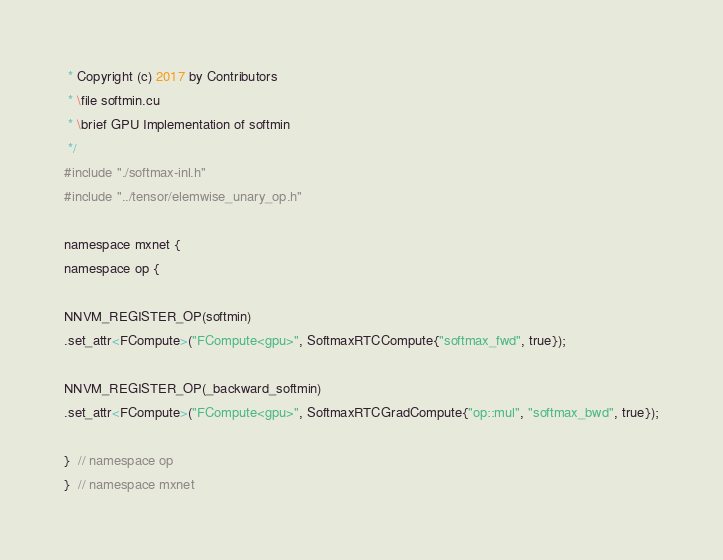Convert code to text. <code><loc_0><loc_0><loc_500><loc_500><_Cuda_> * Copyright (c) 2017 by Contributors
 * \file softmin.cu
 * \brief GPU Implementation of softmin
 */
#include "./softmax-inl.h"
#include "../tensor/elemwise_unary_op.h"

namespace mxnet {
namespace op {

NNVM_REGISTER_OP(softmin)
.set_attr<FCompute>("FCompute<gpu>", SoftmaxRTCCompute{"softmax_fwd", true});

NNVM_REGISTER_OP(_backward_softmin)
.set_attr<FCompute>("FCompute<gpu>", SoftmaxRTCGradCompute{"op::mul", "softmax_bwd", true});

}  // namespace op
}  // namespace mxnet
</code> 